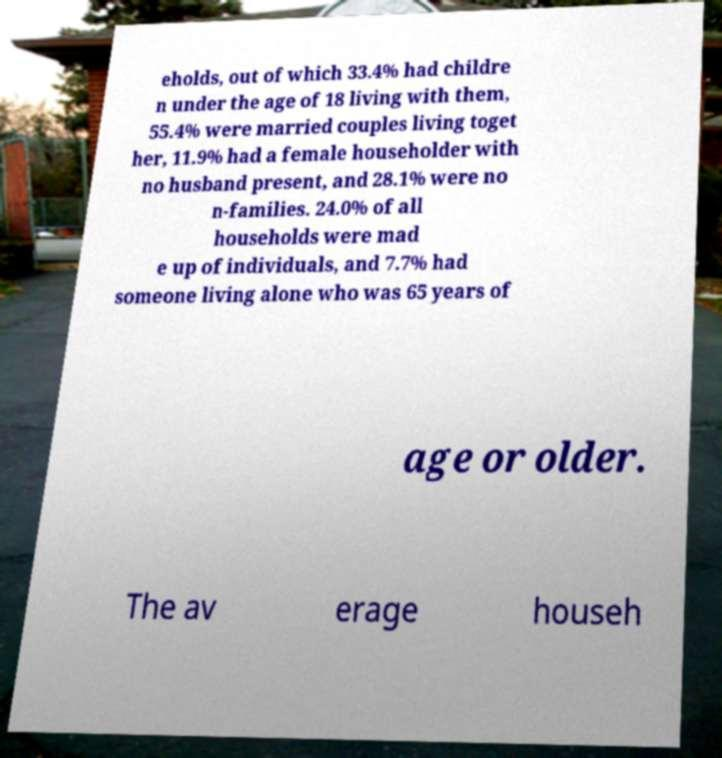Please identify and transcribe the text found in this image. eholds, out of which 33.4% had childre n under the age of 18 living with them, 55.4% were married couples living toget her, 11.9% had a female householder with no husband present, and 28.1% were no n-families. 24.0% of all households were mad e up of individuals, and 7.7% had someone living alone who was 65 years of age or older. The av erage househ 